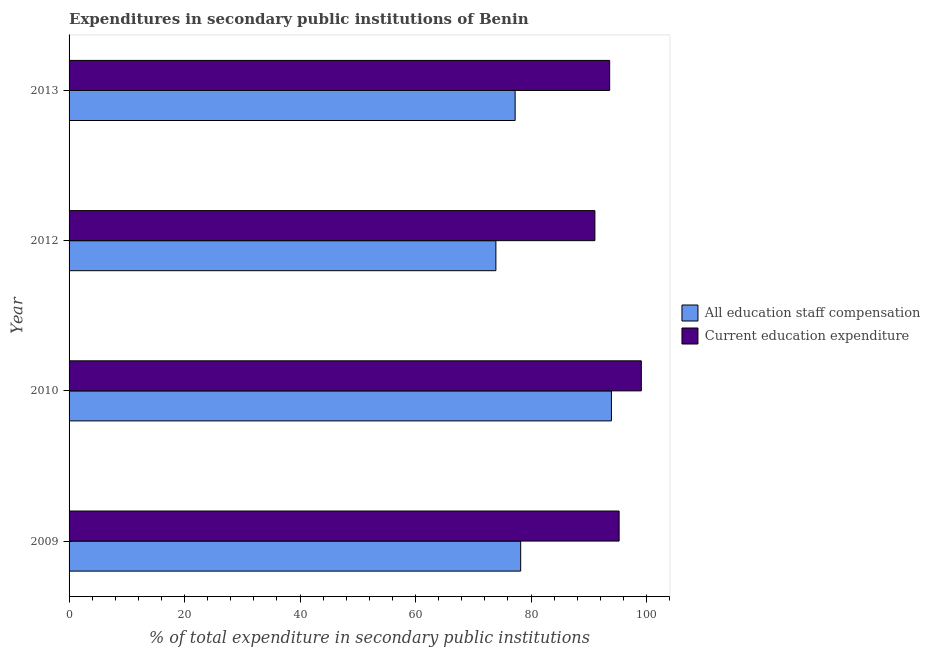Are the number of bars per tick equal to the number of legend labels?
Your response must be concise. Yes. Are the number of bars on each tick of the Y-axis equal?
Your answer should be very brief. Yes. How many bars are there on the 2nd tick from the top?
Give a very brief answer. 2. In how many cases, is the number of bars for a given year not equal to the number of legend labels?
Provide a succinct answer. 0. What is the expenditure in staff compensation in 2010?
Your response must be concise. 93.91. Across all years, what is the maximum expenditure in staff compensation?
Provide a succinct answer. 93.91. Across all years, what is the minimum expenditure in education?
Keep it short and to the point. 91.05. In which year was the expenditure in staff compensation maximum?
Offer a very short reply. 2010. In which year was the expenditure in education minimum?
Provide a short and direct response. 2012. What is the total expenditure in staff compensation in the graph?
Keep it short and to the point. 323.26. What is the difference between the expenditure in education in 2010 and that in 2013?
Your answer should be compact. 5.48. What is the difference between the expenditure in education in 2012 and the expenditure in staff compensation in 2010?
Offer a terse response. -2.86. What is the average expenditure in staff compensation per year?
Your response must be concise. 80.81. In the year 2009, what is the difference between the expenditure in education and expenditure in staff compensation?
Ensure brevity in your answer.  17.05. In how many years, is the expenditure in staff compensation greater than 100 %?
Offer a terse response. 0. What is the ratio of the expenditure in staff compensation in 2010 to that in 2012?
Make the answer very short. 1.27. Is the difference between the expenditure in staff compensation in 2010 and 2013 greater than the difference between the expenditure in education in 2010 and 2013?
Your response must be concise. Yes. What is the difference between the highest and the second highest expenditure in staff compensation?
Provide a succinct answer. 15.72. What is the difference between the highest and the lowest expenditure in education?
Your response must be concise. 8.04. Is the sum of the expenditure in staff compensation in 2009 and 2010 greater than the maximum expenditure in education across all years?
Your response must be concise. Yes. What does the 2nd bar from the top in 2012 represents?
Make the answer very short. All education staff compensation. What does the 1st bar from the bottom in 2010 represents?
Your answer should be compact. All education staff compensation. How many bars are there?
Keep it short and to the point. 8. Are all the bars in the graph horizontal?
Keep it short and to the point. Yes. How many years are there in the graph?
Offer a terse response. 4. What is the difference between two consecutive major ticks on the X-axis?
Offer a very short reply. 20. Does the graph contain grids?
Your answer should be very brief. No. Where does the legend appear in the graph?
Offer a terse response. Center right. What is the title of the graph?
Keep it short and to the point. Expenditures in secondary public institutions of Benin. What is the label or title of the X-axis?
Make the answer very short. % of total expenditure in secondary public institutions. What is the label or title of the Y-axis?
Offer a terse response. Year. What is the % of total expenditure in secondary public institutions in All education staff compensation in 2009?
Ensure brevity in your answer.  78.2. What is the % of total expenditure in secondary public institutions in Current education expenditure in 2009?
Your answer should be very brief. 95.25. What is the % of total expenditure in secondary public institutions of All education staff compensation in 2010?
Offer a terse response. 93.91. What is the % of total expenditure in secondary public institutions of Current education expenditure in 2010?
Ensure brevity in your answer.  99.09. What is the % of total expenditure in secondary public institutions of All education staff compensation in 2012?
Give a very brief answer. 73.91. What is the % of total expenditure in secondary public institutions of Current education expenditure in 2012?
Your answer should be compact. 91.05. What is the % of total expenditure in secondary public institutions in All education staff compensation in 2013?
Ensure brevity in your answer.  77.24. What is the % of total expenditure in secondary public institutions in Current education expenditure in 2013?
Ensure brevity in your answer.  93.61. Across all years, what is the maximum % of total expenditure in secondary public institutions in All education staff compensation?
Keep it short and to the point. 93.91. Across all years, what is the maximum % of total expenditure in secondary public institutions in Current education expenditure?
Provide a short and direct response. 99.09. Across all years, what is the minimum % of total expenditure in secondary public institutions of All education staff compensation?
Your response must be concise. 73.91. Across all years, what is the minimum % of total expenditure in secondary public institutions of Current education expenditure?
Make the answer very short. 91.05. What is the total % of total expenditure in secondary public institutions of All education staff compensation in the graph?
Provide a succinct answer. 323.26. What is the total % of total expenditure in secondary public institutions of Current education expenditure in the graph?
Provide a short and direct response. 379. What is the difference between the % of total expenditure in secondary public institutions of All education staff compensation in 2009 and that in 2010?
Your answer should be compact. -15.72. What is the difference between the % of total expenditure in secondary public institutions in Current education expenditure in 2009 and that in 2010?
Provide a succinct answer. -3.85. What is the difference between the % of total expenditure in secondary public institutions in All education staff compensation in 2009 and that in 2012?
Make the answer very short. 4.29. What is the difference between the % of total expenditure in secondary public institutions of Current education expenditure in 2009 and that in 2012?
Provide a short and direct response. 4.19. What is the difference between the % of total expenditure in secondary public institutions of All education staff compensation in 2009 and that in 2013?
Your response must be concise. 0.96. What is the difference between the % of total expenditure in secondary public institutions of Current education expenditure in 2009 and that in 2013?
Provide a succinct answer. 1.64. What is the difference between the % of total expenditure in secondary public institutions of All education staff compensation in 2010 and that in 2012?
Provide a short and direct response. 20.01. What is the difference between the % of total expenditure in secondary public institutions in Current education expenditure in 2010 and that in 2012?
Provide a succinct answer. 8.04. What is the difference between the % of total expenditure in secondary public institutions of All education staff compensation in 2010 and that in 2013?
Provide a short and direct response. 16.67. What is the difference between the % of total expenditure in secondary public institutions in Current education expenditure in 2010 and that in 2013?
Make the answer very short. 5.48. What is the difference between the % of total expenditure in secondary public institutions of All education staff compensation in 2012 and that in 2013?
Provide a short and direct response. -3.33. What is the difference between the % of total expenditure in secondary public institutions in Current education expenditure in 2012 and that in 2013?
Give a very brief answer. -2.56. What is the difference between the % of total expenditure in secondary public institutions in All education staff compensation in 2009 and the % of total expenditure in secondary public institutions in Current education expenditure in 2010?
Give a very brief answer. -20.89. What is the difference between the % of total expenditure in secondary public institutions of All education staff compensation in 2009 and the % of total expenditure in secondary public institutions of Current education expenditure in 2012?
Provide a succinct answer. -12.85. What is the difference between the % of total expenditure in secondary public institutions in All education staff compensation in 2009 and the % of total expenditure in secondary public institutions in Current education expenditure in 2013?
Keep it short and to the point. -15.41. What is the difference between the % of total expenditure in secondary public institutions in All education staff compensation in 2010 and the % of total expenditure in secondary public institutions in Current education expenditure in 2012?
Keep it short and to the point. 2.86. What is the difference between the % of total expenditure in secondary public institutions of All education staff compensation in 2010 and the % of total expenditure in secondary public institutions of Current education expenditure in 2013?
Provide a short and direct response. 0.31. What is the difference between the % of total expenditure in secondary public institutions of All education staff compensation in 2012 and the % of total expenditure in secondary public institutions of Current education expenditure in 2013?
Ensure brevity in your answer.  -19.7. What is the average % of total expenditure in secondary public institutions of All education staff compensation per year?
Your response must be concise. 80.81. What is the average % of total expenditure in secondary public institutions of Current education expenditure per year?
Ensure brevity in your answer.  94.75. In the year 2009, what is the difference between the % of total expenditure in secondary public institutions of All education staff compensation and % of total expenditure in secondary public institutions of Current education expenditure?
Keep it short and to the point. -17.05. In the year 2010, what is the difference between the % of total expenditure in secondary public institutions in All education staff compensation and % of total expenditure in secondary public institutions in Current education expenditure?
Offer a very short reply. -5.18. In the year 2012, what is the difference between the % of total expenditure in secondary public institutions in All education staff compensation and % of total expenditure in secondary public institutions in Current education expenditure?
Make the answer very short. -17.15. In the year 2013, what is the difference between the % of total expenditure in secondary public institutions in All education staff compensation and % of total expenditure in secondary public institutions in Current education expenditure?
Make the answer very short. -16.37. What is the ratio of the % of total expenditure in secondary public institutions of All education staff compensation in 2009 to that in 2010?
Keep it short and to the point. 0.83. What is the ratio of the % of total expenditure in secondary public institutions of Current education expenditure in 2009 to that in 2010?
Your answer should be very brief. 0.96. What is the ratio of the % of total expenditure in secondary public institutions in All education staff compensation in 2009 to that in 2012?
Keep it short and to the point. 1.06. What is the ratio of the % of total expenditure in secondary public institutions in Current education expenditure in 2009 to that in 2012?
Offer a terse response. 1.05. What is the ratio of the % of total expenditure in secondary public institutions in All education staff compensation in 2009 to that in 2013?
Ensure brevity in your answer.  1.01. What is the ratio of the % of total expenditure in secondary public institutions in Current education expenditure in 2009 to that in 2013?
Offer a very short reply. 1.02. What is the ratio of the % of total expenditure in secondary public institutions of All education staff compensation in 2010 to that in 2012?
Make the answer very short. 1.27. What is the ratio of the % of total expenditure in secondary public institutions in Current education expenditure in 2010 to that in 2012?
Offer a very short reply. 1.09. What is the ratio of the % of total expenditure in secondary public institutions in All education staff compensation in 2010 to that in 2013?
Offer a terse response. 1.22. What is the ratio of the % of total expenditure in secondary public institutions in Current education expenditure in 2010 to that in 2013?
Your answer should be compact. 1.06. What is the ratio of the % of total expenditure in secondary public institutions of All education staff compensation in 2012 to that in 2013?
Your answer should be very brief. 0.96. What is the ratio of the % of total expenditure in secondary public institutions of Current education expenditure in 2012 to that in 2013?
Offer a very short reply. 0.97. What is the difference between the highest and the second highest % of total expenditure in secondary public institutions in All education staff compensation?
Give a very brief answer. 15.72. What is the difference between the highest and the second highest % of total expenditure in secondary public institutions of Current education expenditure?
Keep it short and to the point. 3.85. What is the difference between the highest and the lowest % of total expenditure in secondary public institutions of All education staff compensation?
Provide a short and direct response. 20.01. What is the difference between the highest and the lowest % of total expenditure in secondary public institutions in Current education expenditure?
Your response must be concise. 8.04. 